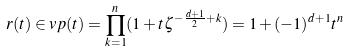Convert formula to latex. <formula><loc_0><loc_0><loc_500><loc_500>r ( t ) \in v p ( t ) = \prod _ { k = 1 } ^ { n } ( 1 + t \zeta ^ { - \frac { d + 1 } 2 + k } ) = 1 + ( - 1 ) ^ { d + 1 } t ^ { n }</formula> 